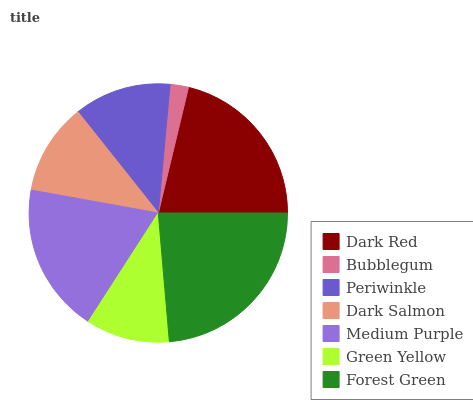Is Bubblegum the minimum?
Answer yes or no. Yes. Is Forest Green the maximum?
Answer yes or no. Yes. Is Periwinkle the minimum?
Answer yes or no. No. Is Periwinkle the maximum?
Answer yes or no. No. Is Periwinkle greater than Bubblegum?
Answer yes or no. Yes. Is Bubblegum less than Periwinkle?
Answer yes or no. Yes. Is Bubblegum greater than Periwinkle?
Answer yes or no. No. Is Periwinkle less than Bubblegum?
Answer yes or no. No. Is Periwinkle the high median?
Answer yes or no. Yes. Is Periwinkle the low median?
Answer yes or no. Yes. Is Bubblegum the high median?
Answer yes or no. No. Is Green Yellow the low median?
Answer yes or no. No. 